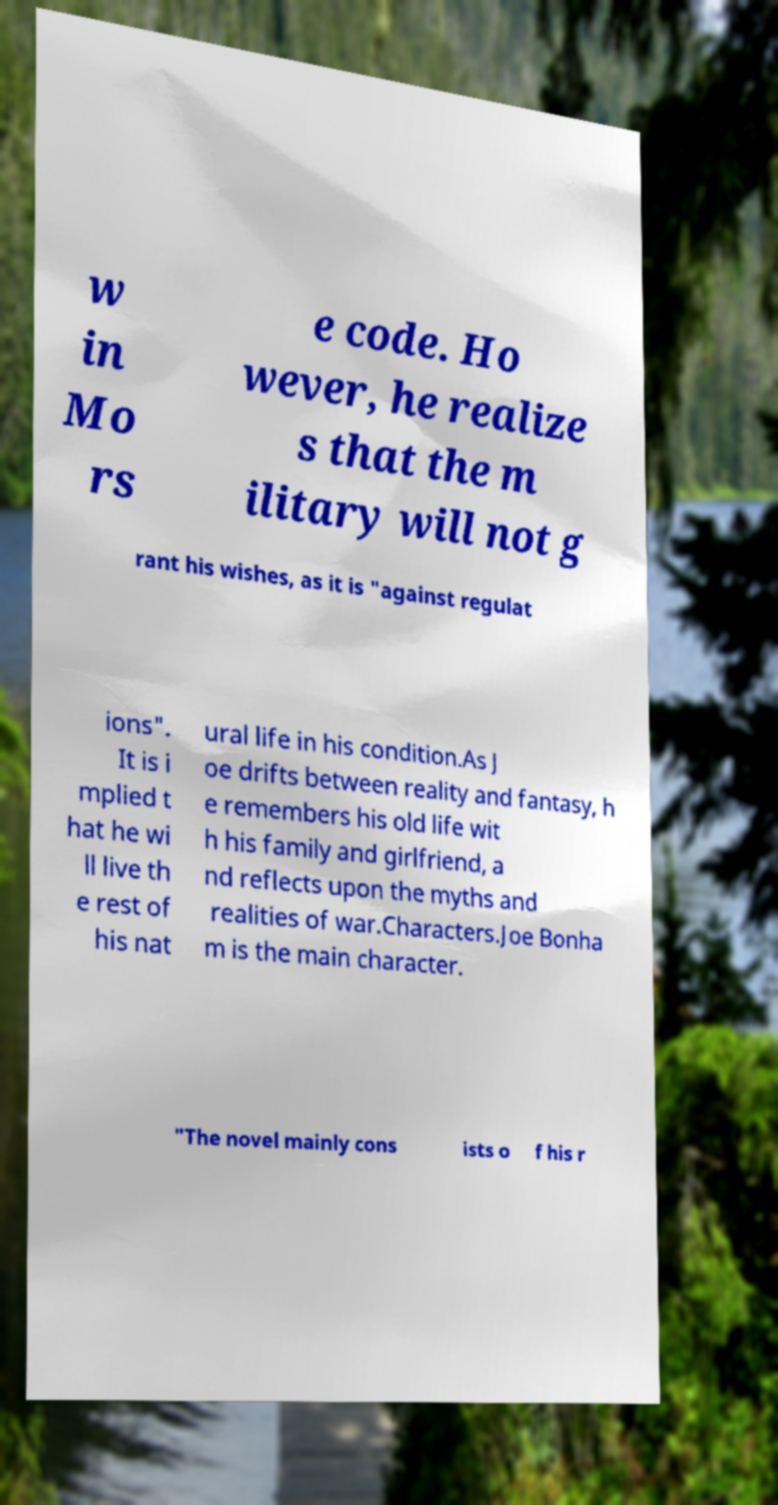What messages or text are displayed in this image? I need them in a readable, typed format. w in Mo rs e code. Ho wever, he realize s that the m ilitary will not g rant his wishes, as it is "against regulat ions". It is i mplied t hat he wi ll live th e rest of his nat ural life in his condition.As J oe drifts between reality and fantasy, h e remembers his old life wit h his family and girlfriend, a nd reflects upon the myths and realities of war.Characters.Joe Bonha m is the main character. "The novel mainly cons ists o f his r 